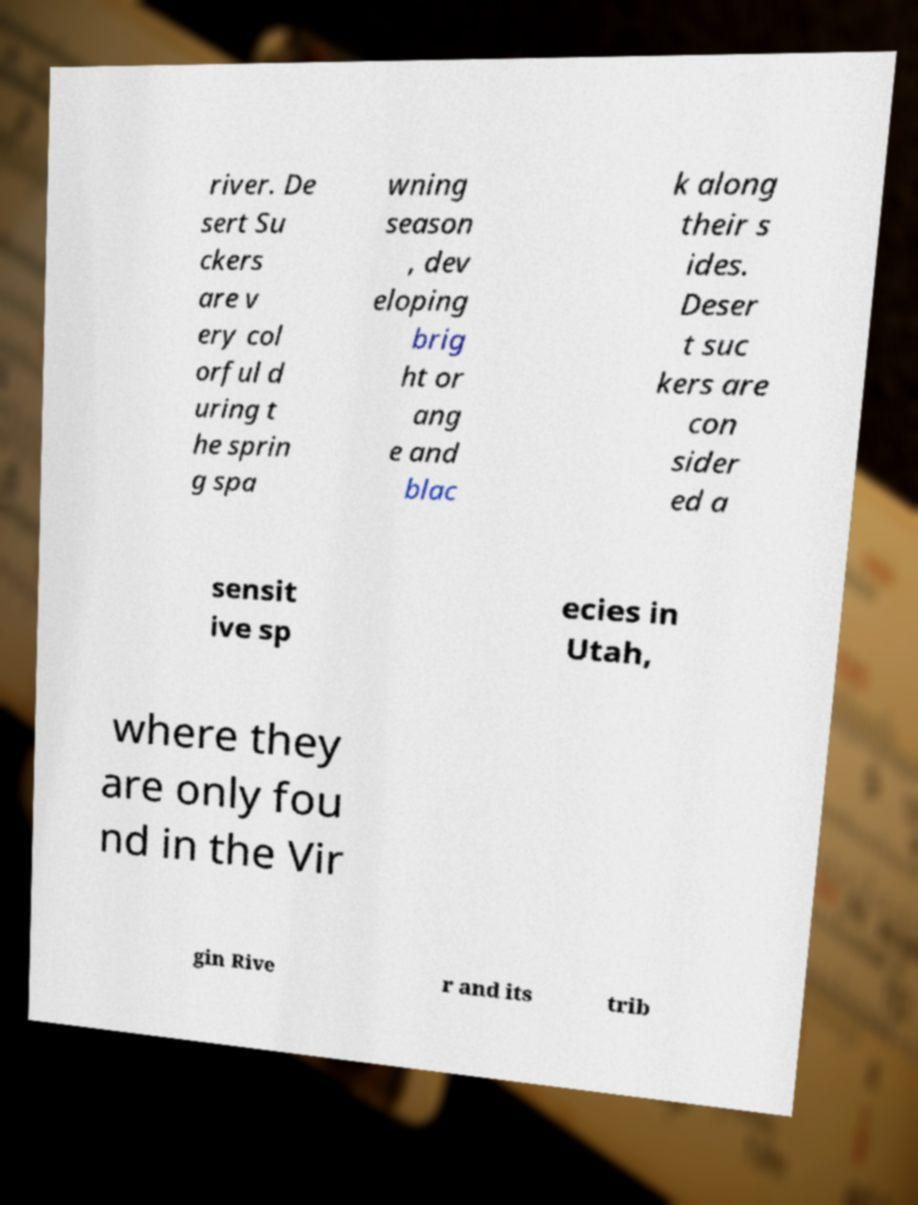For documentation purposes, I need the text within this image transcribed. Could you provide that? river. De sert Su ckers are v ery col orful d uring t he sprin g spa wning season , dev eloping brig ht or ang e and blac k along their s ides. Deser t suc kers are con sider ed a sensit ive sp ecies in Utah, where they are only fou nd in the Vir gin Rive r and its trib 